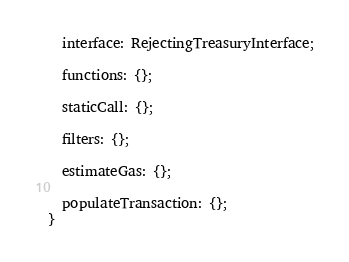Convert code to text. <code><loc_0><loc_0><loc_500><loc_500><_TypeScript_>
  interface: RejectingTreasuryInterface;

  functions: {};

  staticCall: {};

  filters: {};

  estimateGas: {};

  populateTransaction: {};
}
</code> 